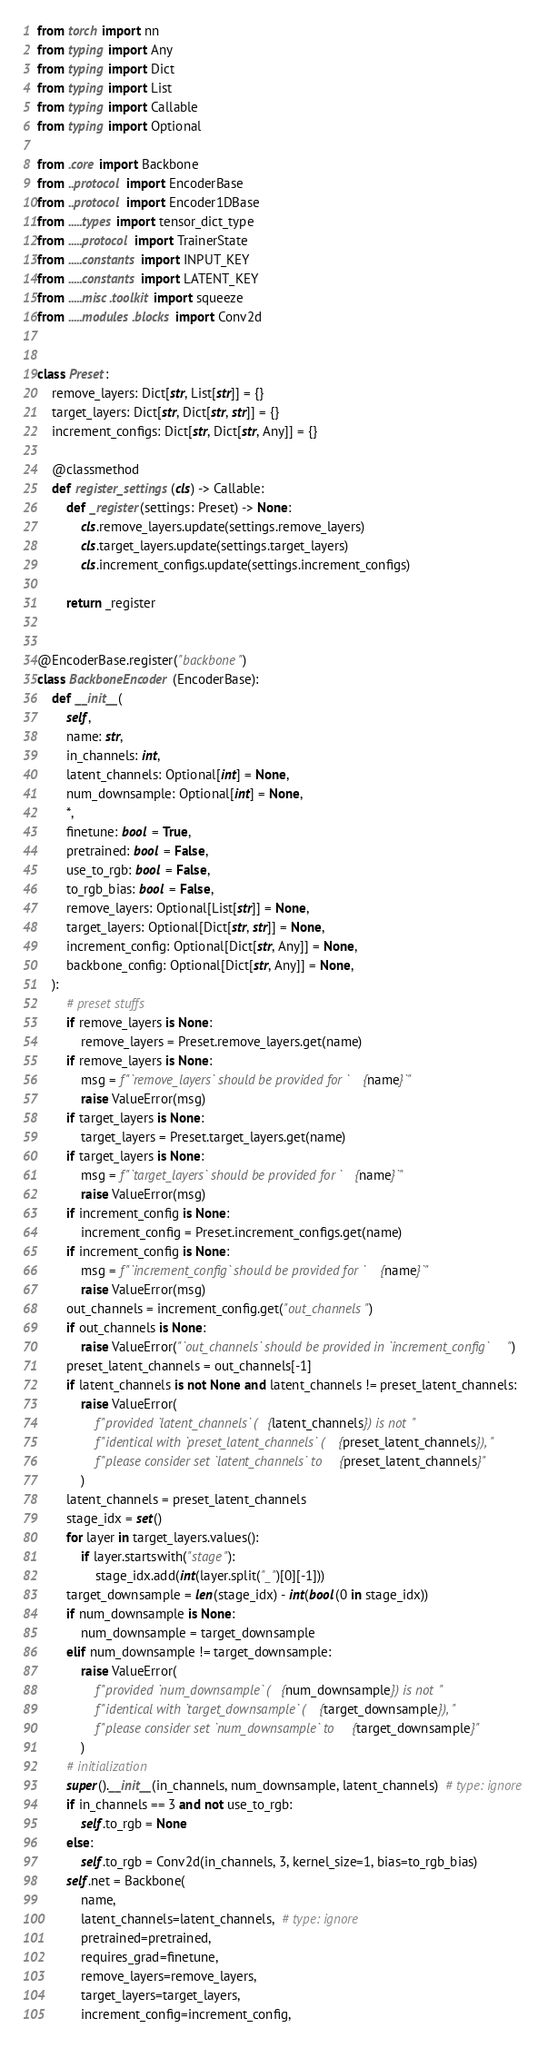Convert code to text. <code><loc_0><loc_0><loc_500><loc_500><_Python_>from torch import nn
from typing import Any
from typing import Dict
from typing import List
from typing import Callable
from typing import Optional

from .core import Backbone
from ..protocol import EncoderBase
from ..protocol import Encoder1DBase
from .....types import tensor_dict_type
from .....protocol import TrainerState
from .....constants import INPUT_KEY
from .....constants import LATENT_KEY
from .....misc.toolkit import squeeze
from .....modules.blocks import Conv2d


class Preset:
    remove_layers: Dict[str, List[str]] = {}
    target_layers: Dict[str, Dict[str, str]] = {}
    increment_configs: Dict[str, Dict[str, Any]] = {}

    @classmethod
    def register_settings(cls) -> Callable:
        def _register(settings: Preset) -> None:
            cls.remove_layers.update(settings.remove_layers)
            cls.target_layers.update(settings.target_layers)
            cls.increment_configs.update(settings.increment_configs)

        return _register


@EncoderBase.register("backbone")
class BackboneEncoder(EncoderBase):
    def __init__(
        self,
        name: str,
        in_channels: int,
        latent_channels: Optional[int] = None,
        num_downsample: Optional[int] = None,
        *,
        finetune: bool = True,
        pretrained: bool = False,
        use_to_rgb: bool = False,
        to_rgb_bias: bool = False,
        remove_layers: Optional[List[str]] = None,
        target_layers: Optional[Dict[str, str]] = None,
        increment_config: Optional[Dict[str, Any]] = None,
        backbone_config: Optional[Dict[str, Any]] = None,
    ):
        # preset stuffs
        if remove_layers is None:
            remove_layers = Preset.remove_layers.get(name)
        if remove_layers is None:
            msg = f"`remove_layers` should be provided for `{name}`"
            raise ValueError(msg)
        if target_layers is None:
            target_layers = Preset.target_layers.get(name)
        if target_layers is None:
            msg = f"`target_layers` should be provided for `{name}`"
            raise ValueError(msg)
        if increment_config is None:
            increment_config = Preset.increment_configs.get(name)
        if increment_config is None:
            msg = f"`increment_config` should be provided for `{name}`"
            raise ValueError(msg)
        out_channels = increment_config.get("out_channels")
        if out_channels is None:
            raise ValueError("`out_channels` should be provided in `increment_config`")
        preset_latent_channels = out_channels[-1]
        if latent_channels is not None and latent_channels != preset_latent_channels:
            raise ValueError(
                f"provided `latent_channels` ({latent_channels}) is not "
                f"identical with `preset_latent_channels` ({preset_latent_channels}), "
                f"please consider set `latent_channels` to {preset_latent_channels}"
            )
        latent_channels = preset_latent_channels
        stage_idx = set()
        for layer in target_layers.values():
            if layer.startswith("stage"):
                stage_idx.add(int(layer.split("_")[0][-1]))
        target_downsample = len(stage_idx) - int(bool(0 in stage_idx))
        if num_downsample is None:
            num_downsample = target_downsample
        elif num_downsample != target_downsample:
            raise ValueError(
                f"provided `num_downsample` ({num_downsample}) is not "
                f"identical with `target_downsample` ({target_downsample}), "
                f"please consider set `num_downsample` to {target_downsample}"
            )
        # initialization
        super().__init__(in_channels, num_downsample, latent_channels)  # type: ignore
        if in_channels == 3 and not use_to_rgb:
            self.to_rgb = None
        else:
            self.to_rgb = Conv2d(in_channels, 3, kernel_size=1, bias=to_rgb_bias)
        self.net = Backbone(
            name,
            latent_channels=latent_channels,  # type: ignore
            pretrained=pretrained,
            requires_grad=finetune,
            remove_layers=remove_layers,
            target_layers=target_layers,
            increment_config=increment_config,</code> 